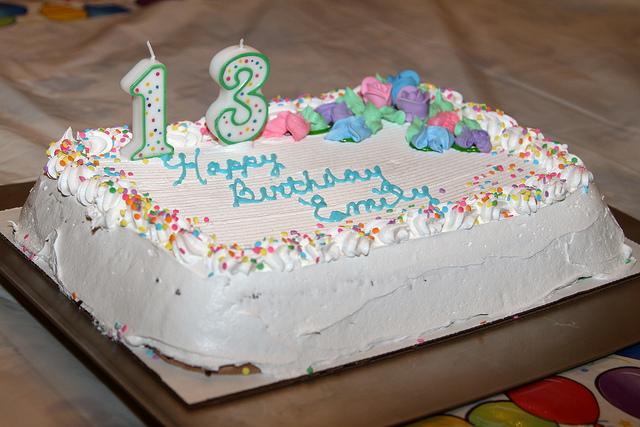What type of vehicle is on the cake?
Keep it brief. None. Is this cake for a baby boy?
Give a very brief answer. No. What is on this cake?
Give a very brief answer. Frosting. Is Emily Celebrating 13 years of school?
Write a very short answer. No. Is the entire message on the cake visible?
Answer briefly. Yes. What number is on cake?
Concise answer only. 13. How old is Emily?
Quick response, please. 13. What color is the frosting?
Concise answer only. White. What age is the child having a birthday?
Write a very short answer. 13. About how many slices of cake are left?
Give a very brief answer. All of them. 